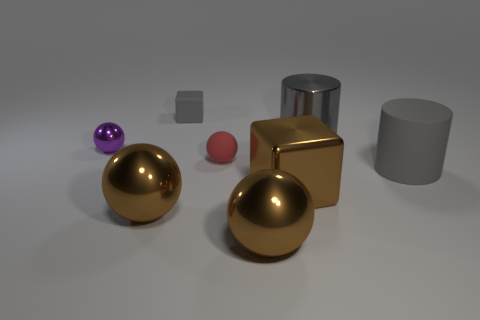There is a shiny thing right of the big brown metal block; is it the same color as the cube that is behind the brown shiny cube?
Keep it short and to the point. Yes. Are there fewer small red objects that are to the left of the purple metallic object than big brown shiny spheres on the right side of the tiny gray matte object?
Your answer should be very brief. Yes. The gray matte thing that is to the right of the tiny red ball has what shape?
Give a very brief answer. Cylinder. What is the material of the small object that is the same color as the matte cylinder?
Keep it short and to the point. Rubber. What number of other things are there of the same material as the small gray object
Provide a short and direct response. 2. Do the big rubber thing and the big shiny object that is right of the brown block have the same shape?
Offer a terse response. Yes. There is a purple object that is made of the same material as the big brown block; what is its shape?
Your answer should be very brief. Sphere. Are there more cylinders that are in front of the gray metallic cylinder than brown objects behind the metal cube?
Keep it short and to the point. Yes. How many things are small blue matte spheres or tiny gray objects?
Your answer should be compact. 1. What number of other objects are the same color as the small block?
Give a very brief answer. 2. 